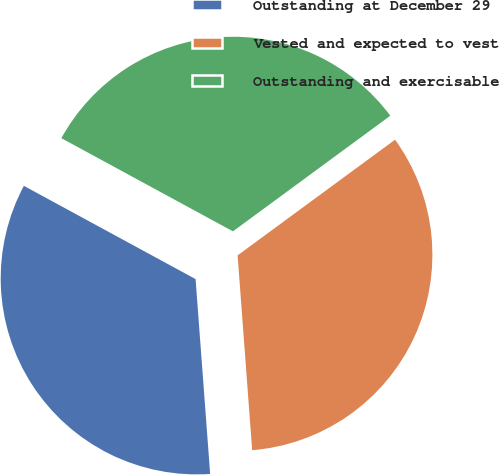Convert chart to OTSL. <chart><loc_0><loc_0><loc_500><loc_500><pie_chart><fcel>Outstanding at December 29<fcel>Vested and expected to vest<fcel>Outstanding and exercisable<nl><fcel>34.11%<fcel>33.9%<fcel>32.0%<nl></chart> 